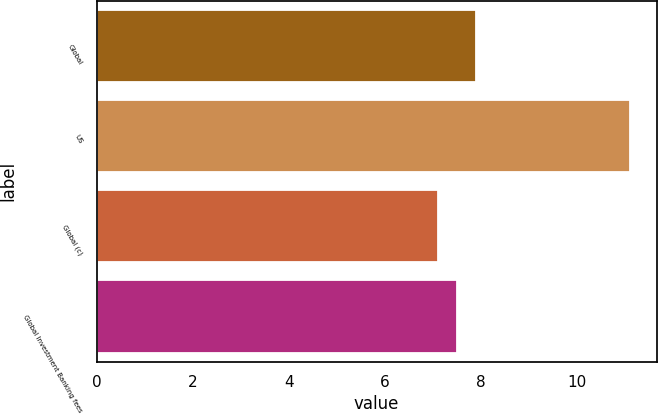Convert chart to OTSL. <chart><loc_0><loc_0><loc_500><loc_500><bar_chart><fcel>Global<fcel>US<fcel>Global (c)<fcel>Global Investment Banking fees<nl><fcel>7.9<fcel>11.1<fcel>7.1<fcel>7.5<nl></chart> 